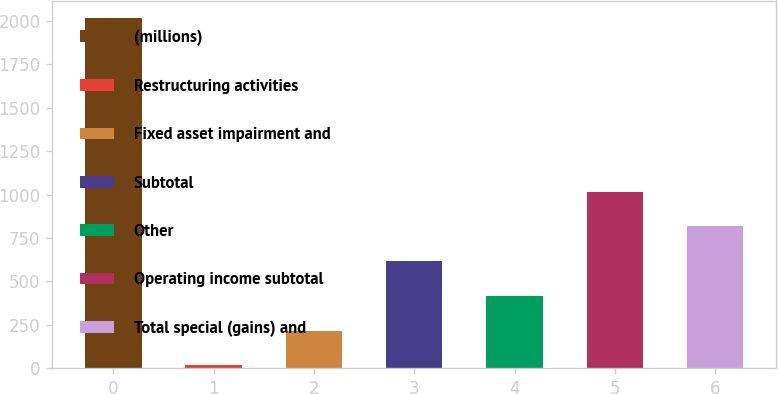Convert chart. <chart><loc_0><loc_0><loc_500><loc_500><bar_chart><fcel>(millions)<fcel>Restructuring activities<fcel>Fixed asset impairment and<fcel>Subtotal<fcel>Other<fcel>Operating income subtotal<fcel>Total special (gains) and<nl><fcel>2015<fcel>16.5<fcel>216.35<fcel>616.05<fcel>416.2<fcel>1015.75<fcel>815.9<nl></chart> 